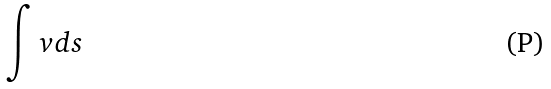Convert formula to latex. <formula><loc_0><loc_0><loc_500><loc_500>\int v d s</formula> 